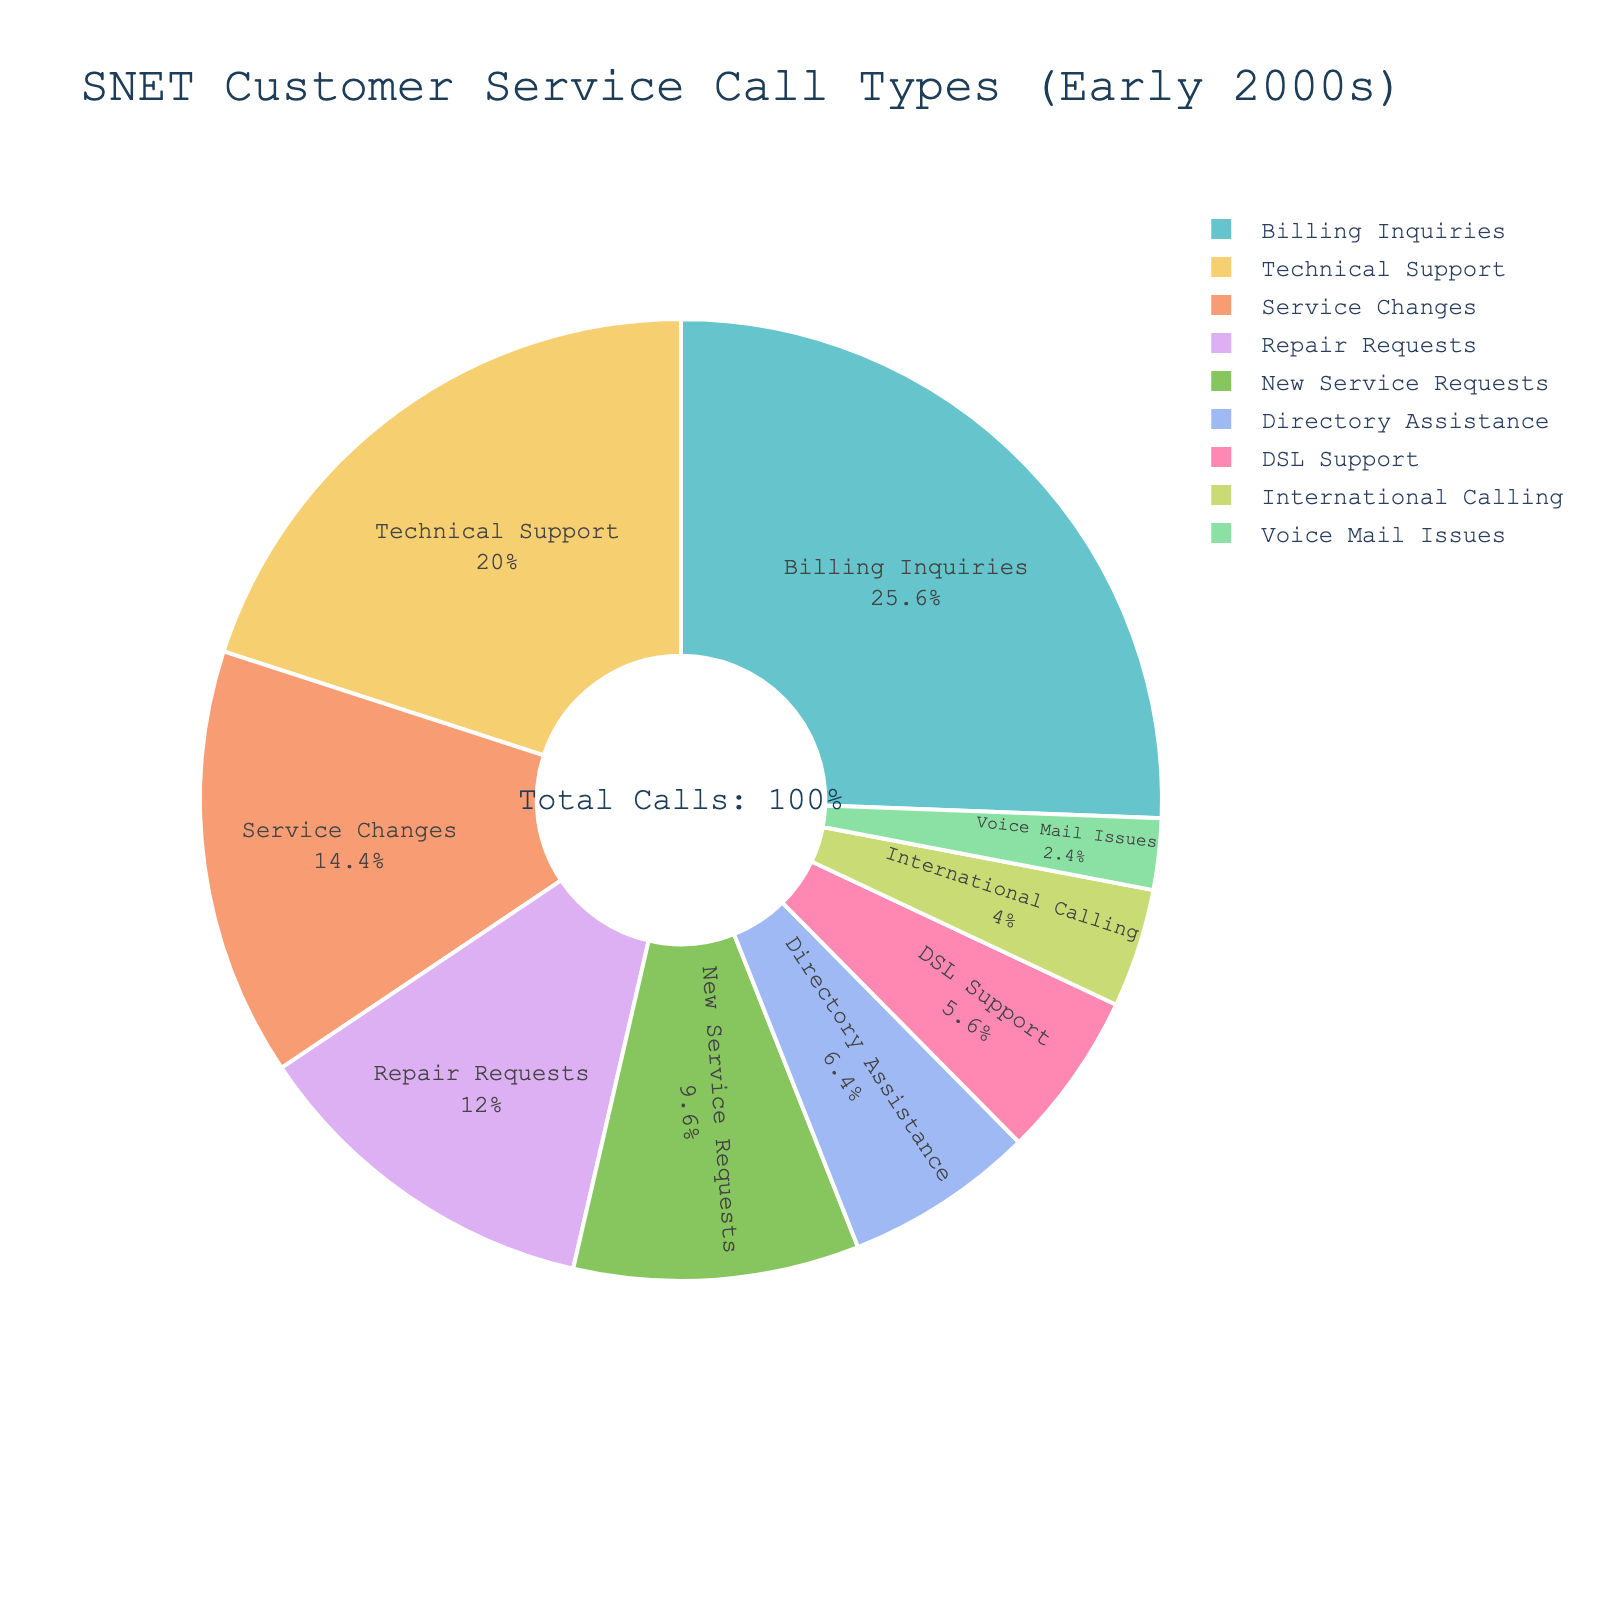What percentage of customer service calls were related to billing inquiries? The chart shows a section labeled "Billing Inquiries" with its percentage.
Answer: 32% Which call type had the lowest percentage, and what is it? From the pie chart, identify the section with the smallest slice and look at its label. Voice Mail Issues is the smallest.
Answer: Voice Mail Issues, 3% How much higher is the percentage of Billing Inquiries compared to New Service Requests? Find the percentages for both Billing Inquiries (32%) and New Service Requests (12%) and compute the difference. 32% - 12% = 20%
Answer: 20% What combined percentage do Service Changes and DSL Support represent? Add the percentages for Service Changes (18%) and DSL Support (7%). 18% + 7% = 25%
Answer: 25% Is the percentage of Technical Support calls greater than the percentage of Repair Requests? By how much? Compare the percentages of Technical Support (25%) and Repair Requests (15%) by subtracting the smaller from the larger. 25% - 15% = 10%
Answer: Yes, by 10% Which call type accounts for the second largest percentage of calls, and what is that percentage? Identify the largest percentage segment first (Billing Inquiries, 32%), then find the second largest segment, which is Technical Support at 25%.
Answer: Technical Support, 25% Rank the call types in descending order of their percentage representation. Arrange the call types in order starting from the highest percentage to the lowest.
Answer: Billing Inquiries, Technical Support, Service Changes, Repair Requests, New Service Requests, Directory Assistance, DSL Support, International Calling, Voice Mail Issues What percentage of calls is dedicated to International Calling and Voice Mail Issues combined? Add the percentages for International Calling (5%) and Voice Mail Issues (3%). 5% + 3% = 8%
Answer: 8% Are there more calls related to Directory Assistance or DSL Support? By how much? Compare the percentages for Directory Assistance (8%) and DSL Support (7%) by subtracting the smaller from the larger. 8% - 7% = 1%
Answer: Directory Assistance, by 1% Which call types collectively make up exactly 50% of the total percentage of calls? Identify combinations of call types that add up to 50%. For one combination: Service Changes (18%) + Technical Support (25%) + Voice Mail Issues (3%) + DSL Support (7%) = 53%. Another combination: Repair Requests (15%) + New Service Requests (12%) + Directory Assistance (8%) + DSL Support (7%) + International Calling (5%) + Voice Mail Issues (3%) = 50%.
Answer: Repair Requests, New Service Requests, Directory Assistance, DSL Support, International Calling, Voice Mail Issues 